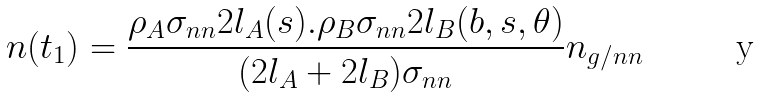Convert formula to latex. <formula><loc_0><loc_0><loc_500><loc_500>n ( t _ { 1 } ) = \frac { \rho _ { A } \sigma _ { n n } 2 l _ { A } ( s ) . \rho _ { B } \sigma _ { n n } 2 l _ { B } ( b , s , \theta ) } { ( 2 l _ { A } + 2 l _ { B } ) \sigma _ { n n } } n _ { g / n n }</formula> 